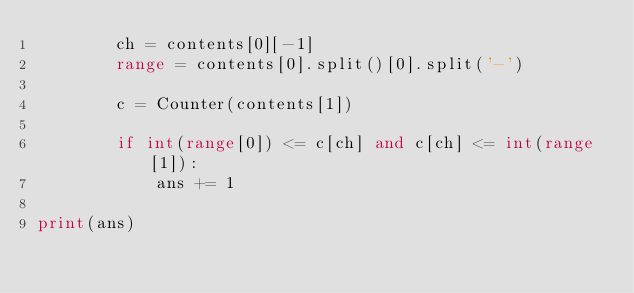<code> <loc_0><loc_0><loc_500><loc_500><_Python_>        ch = contents[0][-1]
        range = contents[0].split()[0].split('-')

        c = Counter(contents[1])

        if int(range[0]) <= c[ch] and c[ch] <= int(range[1]):
            ans += 1

print(ans)
</code> 